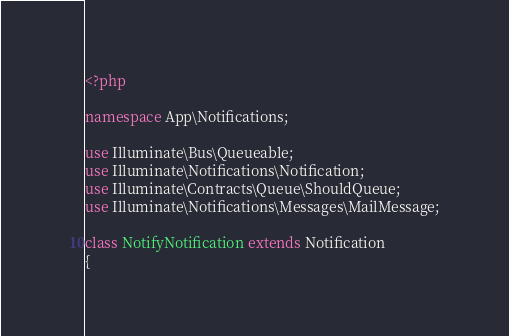Convert code to text. <code><loc_0><loc_0><loc_500><loc_500><_PHP_><?php

namespace App\Notifications;

use Illuminate\Bus\Queueable;
use Illuminate\Notifications\Notification;
use Illuminate\Contracts\Queue\ShouldQueue;
use Illuminate\Notifications\Messages\MailMessage;

class NotifyNotification extends Notification
{</code> 